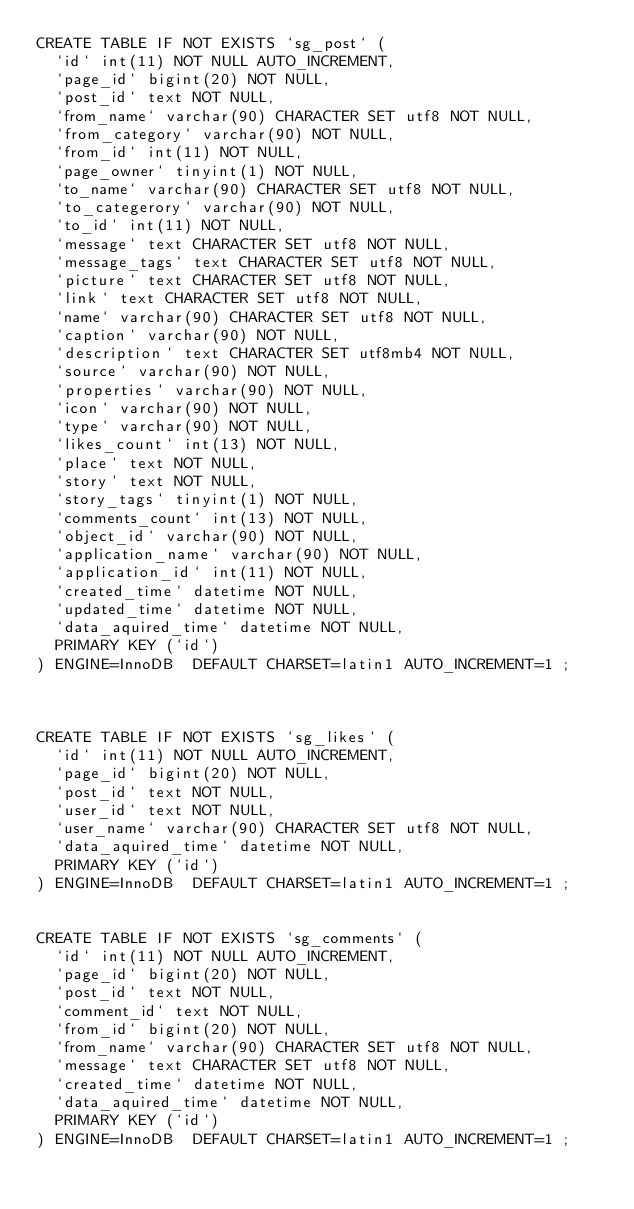<code> <loc_0><loc_0><loc_500><loc_500><_SQL_>CREATE TABLE IF NOT EXISTS `sg_post` (
  `id` int(11) NOT NULL AUTO_INCREMENT,
  `page_id` bigint(20) NOT NULL,
  `post_id` text NOT NULL,
  `from_name` varchar(90) CHARACTER SET utf8 NOT NULL,
  `from_category` varchar(90) NOT NULL,
  `from_id` int(11) NOT NULL,
  `page_owner` tinyint(1) NOT NULL,
  `to_name` varchar(90) CHARACTER SET utf8 NOT NULL,
  `to_categerory` varchar(90) NOT NULL,
  `to_id` int(11) NOT NULL,
  `message` text CHARACTER SET utf8 NOT NULL,
  `message_tags` text CHARACTER SET utf8 NOT NULL,
  `picture` text CHARACTER SET utf8 NOT NULL,
  `link` text CHARACTER SET utf8 NOT NULL,
  `name` varchar(90) CHARACTER SET utf8 NOT NULL,
  `caption` varchar(90) NOT NULL,
  `description` text CHARACTER SET utf8mb4 NOT NULL,
  `source` varchar(90) NOT NULL,
  `properties` varchar(90) NOT NULL,
  `icon` varchar(90) NOT NULL,
  `type` varchar(90) NOT NULL,
  `likes_count` int(13) NOT NULL,
  `place` text NOT NULL,
  `story` text NOT NULL,
  `story_tags` tinyint(1) NOT NULL,
  `comments_count` int(13) NOT NULL,
  `object_id` varchar(90) NOT NULL,
  `application_name` varchar(90) NOT NULL,
  `application_id` int(11) NOT NULL,
  `created_time` datetime NOT NULL,
  `updated_time` datetime NOT NULL,
  `data_aquired_time` datetime NOT NULL,
  PRIMARY KEY (`id`)
) ENGINE=InnoDB  DEFAULT CHARSET=latin1 AUTO_INCREMENT=1 ;



CREATE TABLE IF NOT EXISTS `sg_likes` (
  `id` int(11) NOT NULL AUTO_INCREMENT,
  `page_id` bigint(20) NOT NULL,
  `post_id` text NOT NULL,
  `user_id` text NOT NULL,
  `user_name` varchar(90) CHARACTER SET utf8 NOT NULL,
  `data_aquired_time` datetime NOT NULL,
  PRIMARY KEY (`id`)
) ENGINE=InnoDB  DEFAULT CHARSET=latin1 AUTO_INCREMENT=1 ;


CREATE TABLE IF NOT EXISTS `sg_comments` (
  `id` int(11) NOT NULL AUTO_INCREMENT,
  `page_id` bigint(20) NOT NULL,
  `post_id` text NOT NULL,
  `comment_id` text NOT NULL,
  `from_id` bigint(20) NOT NULL,
  `from_name` varchar(90) CHARACTER SET utf8 NOT NULL,
  `message` text CHARACTER SET utf8 NOT NULL,
  `created_time` datetime NOT NULL,
  `data_aquired_time` datetime NOT NULL,
  PRIMARY KEY (`id`)
) ENGINE=InnoDB  DEFAULT CHARSET=latin1 AUTO_INCREMENT=1 ;</code> 